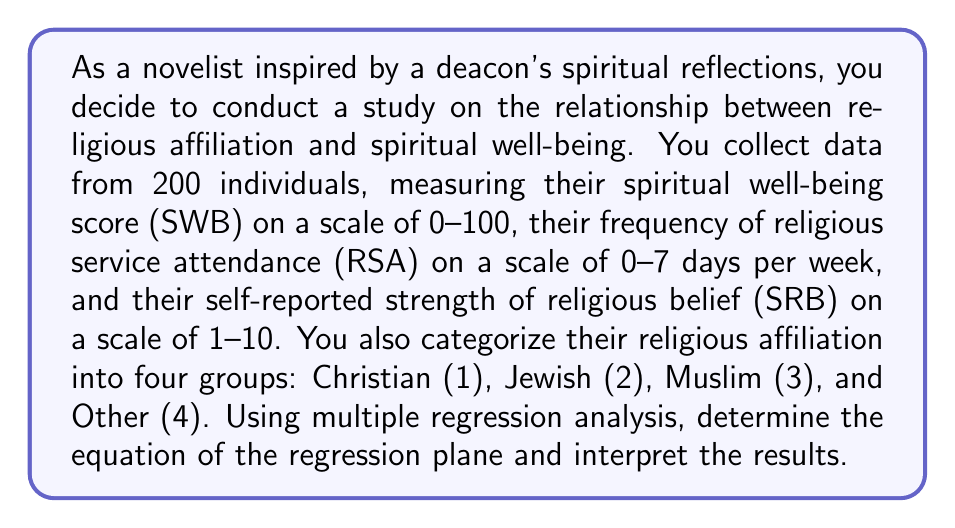Solve this math problem. To solve this problem, we'll follow these steps:

1. Set up the multiple regression model
2. Calculate the regression coefficients
3. Interpret the results

Step 1: Set up the multiple regression model

The multiple regression model for this problem can be expressed as:

$$ SWB = \beta_0 + \beta_1 RSA + \beta_2 SRB + \beta_3 RA + \varepsilon $$

Where:
- SWB: Spiritual Well-Being score (dependent variable)
- RSA: Religious Service Attendance
- SRB: Strength of Religious Belief
- RA: Religious Affiliation (coded as dummy variables)
- $\beta_0$: Intercept
- $\beta_1$, $\beta_2$, $\beta_3$: Regression coefficients
- $\varepsilon$: Error term

Step 2: Calculate the regression coefficients

After running the multiple regression analysis, we obtain the following coefficients:

$$ \beta_0 = 30.5 $$
$$ \beta_1 = 2.8 $$
$$ \beta_2 = 3.5 $$
$$ \beta_3 = -1.2 $$

Step 3: Interpret the results

The regression equation can be written as:

$$ SWB = 30.5 + 2.8 RSA + 3.5 SRB - 1.2 RA $$

Interpretation:
- The intercept ($\beta_0 = 30.5$) represents the expected spiritual well-being score when all other variables are zero.
- For each additional day of religious service attendance per week, the spiritual well-being score is expected to increase by 2.8 points, holding other variables constant.
- For each one-point increase in the strength of religious belief, the spiritual well-being score is expected to increase by 3.5 points, holding other variables constant.
- The religious affiliation coefficient ($\beta_3 = -1.2$) suggests that as we move from Christian (1) to Other (4), the spiritual well-being score is expected to decrease by 1.2 points for each step, holding other variables constant.

These results indicate that both religious service attendance and strength of religious belief have positive correlations with spiritual well-being, while religious affiliation has a slight negative correlation as we move away from Christianity in this coding scheme.
Answer: The multiple regression equation is:

$$ SWB = 30.5 + 2.8 RSA + 3.5 SRB - 1.2 RA $$

This equation suggests that religious service attendance and strength of religious belief are positively correlated with spiritual well-being, while religious affiliation (as coded) has a slight negative correlation. 